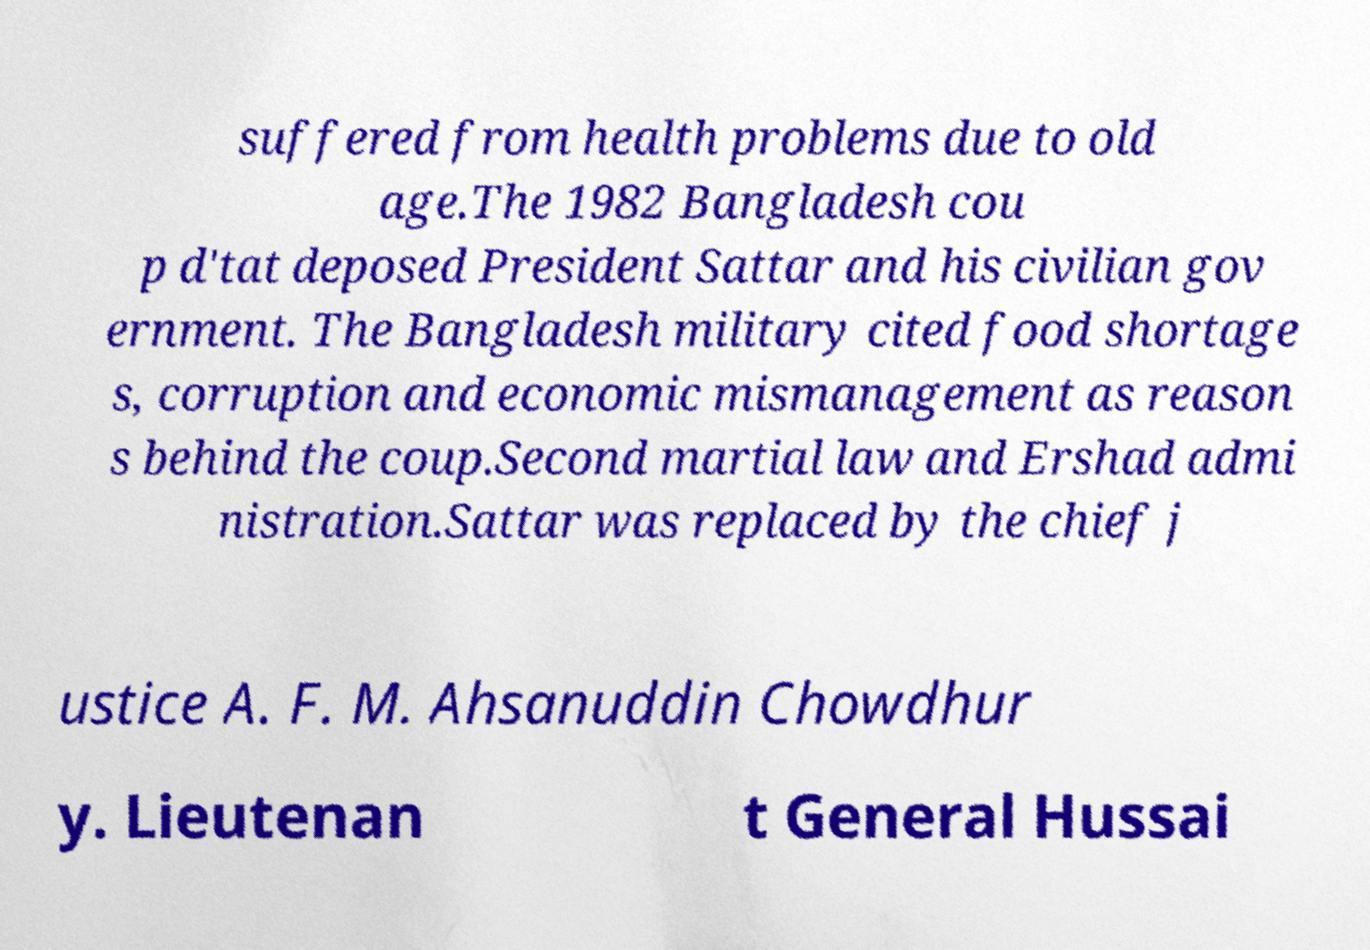Please read and relay the text visible in this image. What does it say? suffered from health problems due to old age.The 1982 Bangladesh cou p d'tat deposed President Sattar and his civilian gov ernment. The Bangladesh military cited food shortage s, corruption and economic mismanagement as reason s behind the coup.Second martial law and Ershad admi nistration.Sattar was replaced by the chief j ustice A. F. M. Ahsanuddin Chowdhur y. Lieutenan t General Hussai 